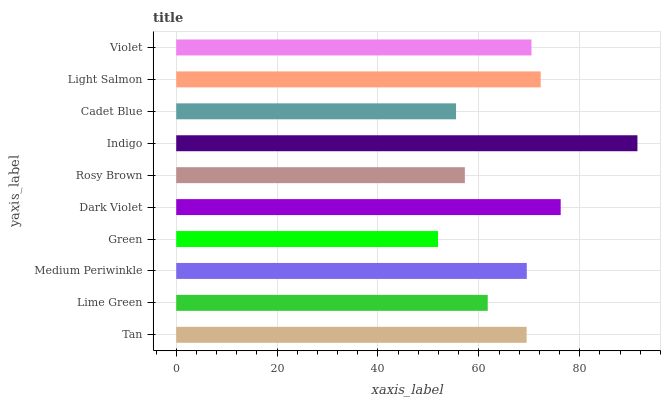Is Green the minimum?
Answer yes or no. Yes. Is Indigo the maximum?
Answer yes or no. Yes. Is Lime Green the minimum?
Answer yes or no. No. Is Lime Green the maximum?
Answer yes or no. No. Is Tan greater than Lime Green?
Answer yes or no. Yes. Is Lime Green less than Tan?
Answer yes or no. Yes. Is Lime Green greater than Tan?
Answer yes or no. No. Is Tan less than Lime Green?
Answer yes or no. No. Is Medium Periwinkle the high median?
Answer yes or no. Yes. Is Tan the low median?
Answer yes or no. Yes. Is Rosy Brown the high median?
Answer yes or no. No. Is Indigo the low median?
Answer yes or no. No. 